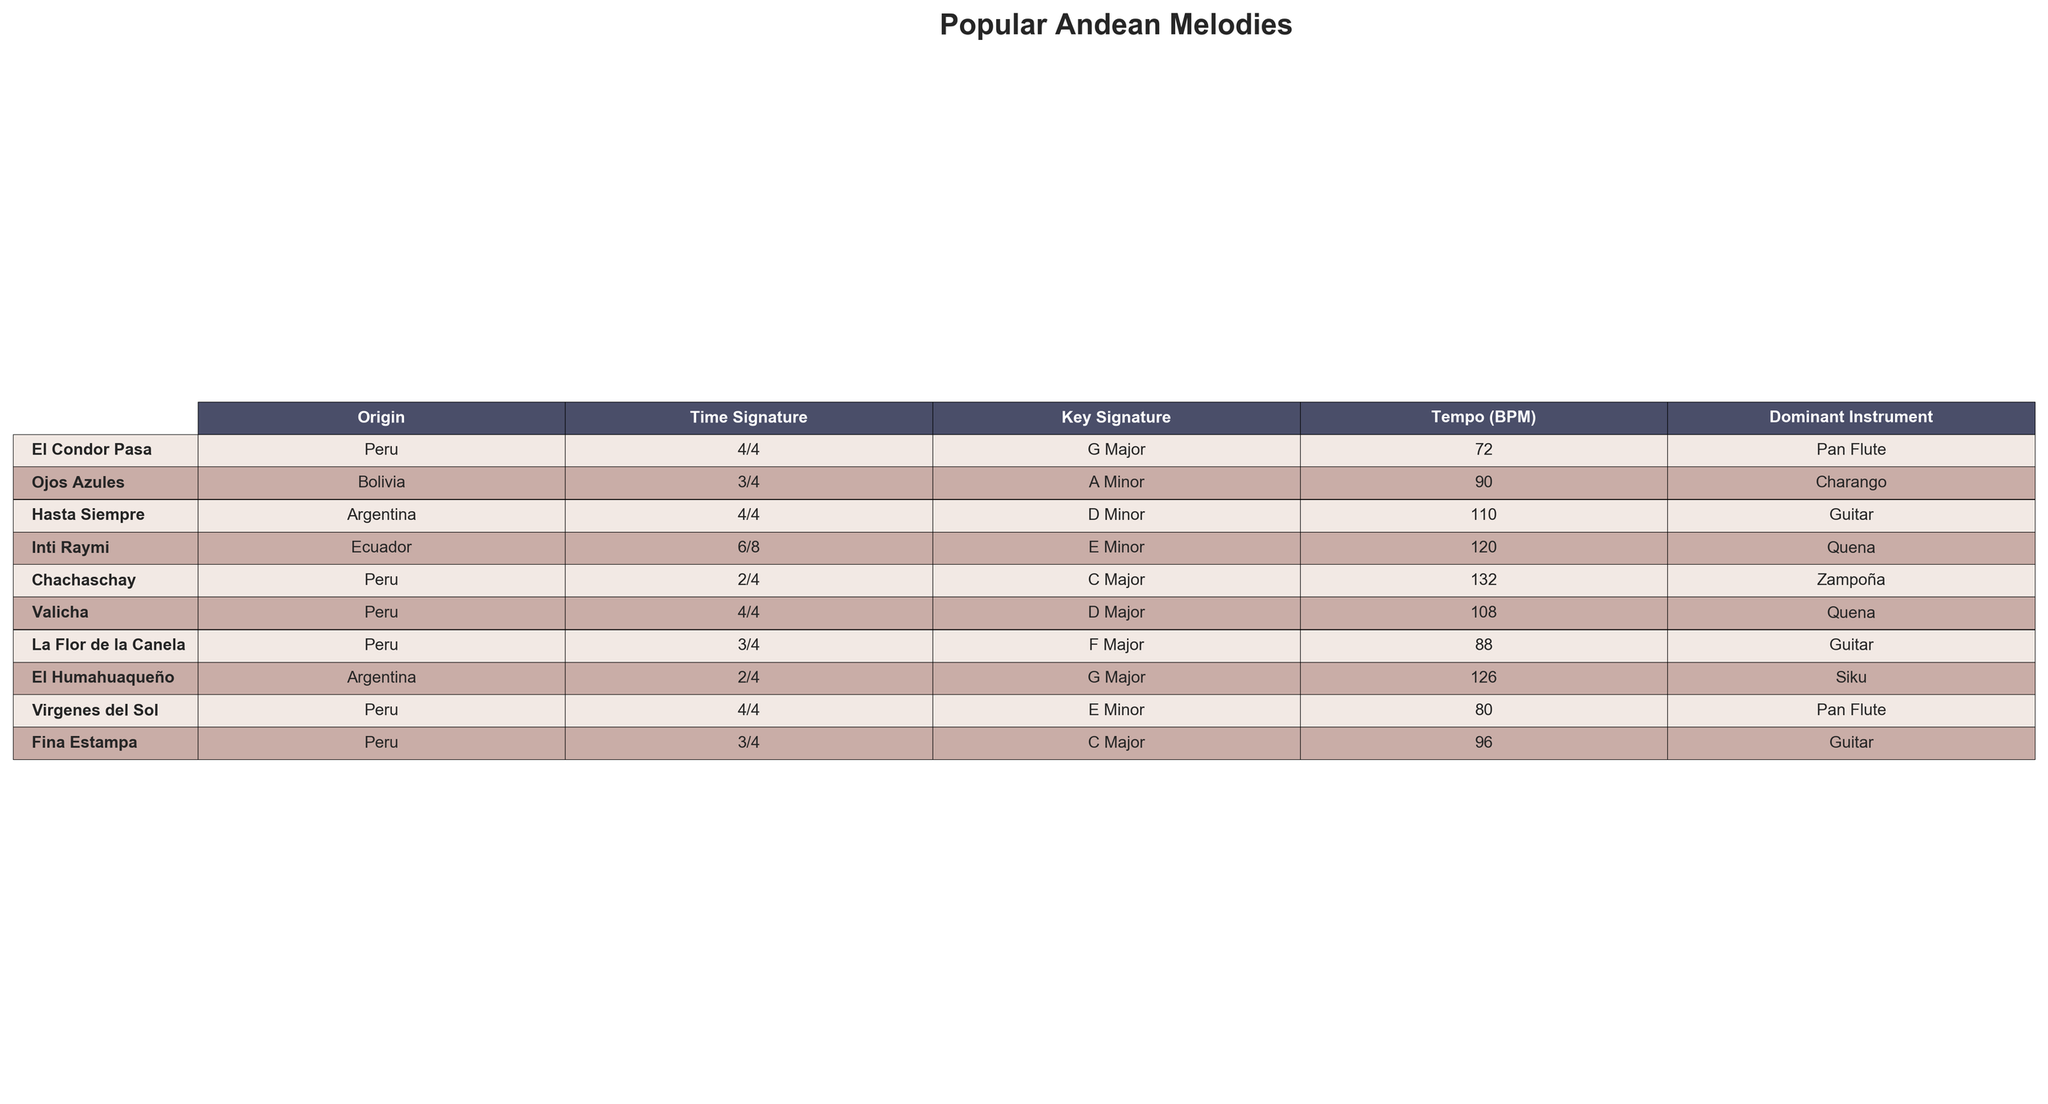What's the dominant instrument used in "Ojos Azules"? Referring to the table, under the column "Dominant Instrument" for the melody "Ojos Azules," the value listed is "Charango."
Answer: Charango Which melody has the highest tempo? Looking at the "Tempo (BPM)" column, "Chachaschay" has the highest value at 132 BPM.
Answer: Chachaschay Is the emotion expressed in "El Humahuaqueño" considered joyful? The table indicates that the typical emotion for "El Humahuaqueño" is "Energetic," which does not directly mean joyful, so it is false.
Answer: No What is the average verse length of all melodies? To find the average verse length, add all verse lengths (16 + 12 + 16 + 24 + 8 + 16 + 16 + 12 + 20 + 16) = 128. There are 10 melodies, so the average is 128/10 = 12.8 bars.
Answer: 12.8 bars Which melody from Peru has a moderate modern adaptation popularity? By scanning the "Modern Adaptation Popularity" column, "Chachaschay" from Peru has a "Moderate" rating for popularity.
Answer: Chachaschay Are all melodies in major keys? By examining the "Key Signature" column, not all melodies are in major keys; for instance, "Ojos Azules" and "Hasta Siempre" are in minor keys, so the overall statement is false.
Answer: No Which melody has the longest chorus length and how long is it? After reviewing the "Chorus Length (Bars)" column, "Inti Raymi" has the longest chorus at 12 bars.
Answer: 12 bars What proportion of melodies are in 4/4 time signature? There are a total of 10 melodies. The melodies in 4/4 time signature are "El Condor Pasa," "Hasta Siempre," "Valicha," "Virgenes del Sol," giving us 4 out of 10, which is a proportion of 40%.
Answer: 40% Which two melodies have a traditional dance associated with them? By looking at the "Traditional Dance" column, both "Huayno" and "Cueca" are linked with melodies that correspond to their respective entries.
Answer: Huayno, Cueca Which melody expresses a sentimental emotion and is from Peru? By checking the "Typical Emotion" and "Origin" columns, "La Flor de la Canela" meets both criteria as it is from Peru and expresses sentimentality.
Answer: La Flor de la Canela 